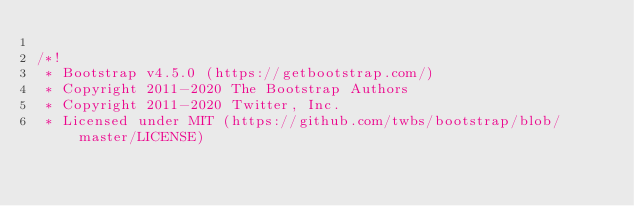<code> <loc_0><loc_0><loc_500><loc_500><_CSS_>
/*!
 * Bootstrap v4.5.0 (https://getbootstrap.com/)
 * Copyright 2011-2020 The Bootstrap Authors
 * Copyright 2011-2020 Twitter, Inc.
 * Licensed under MIT (https://github.com/twbs/bootstrap/blob/master/LICENSE)</code> 